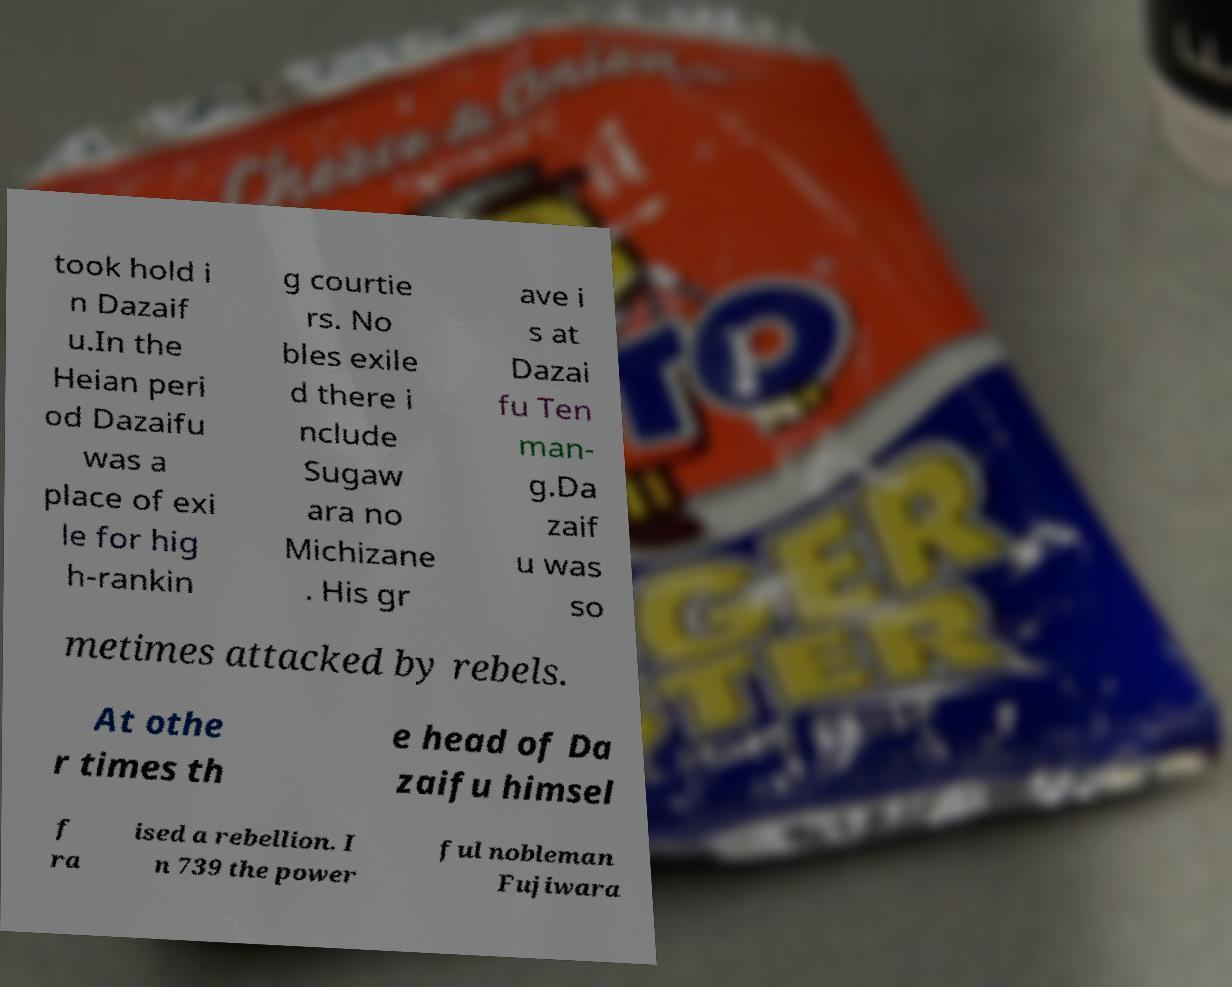Please read and relay the text visible in this image. What does it say? took hold i n Dazaif u.In the Heian peri od Dazaifu was a place of exi le for hig h-rankin g courtie rs. No bles exile d there i nclude Sugaw ara no Michizane . His gr ave i s at Dazai fu Ten man- g.Da zaif u was so metimes attacked by rebels. At othe r times th e head of Da zaifu himsel f ra ised a rebellion. I n 739 the power ful nobleman Fujiwara 